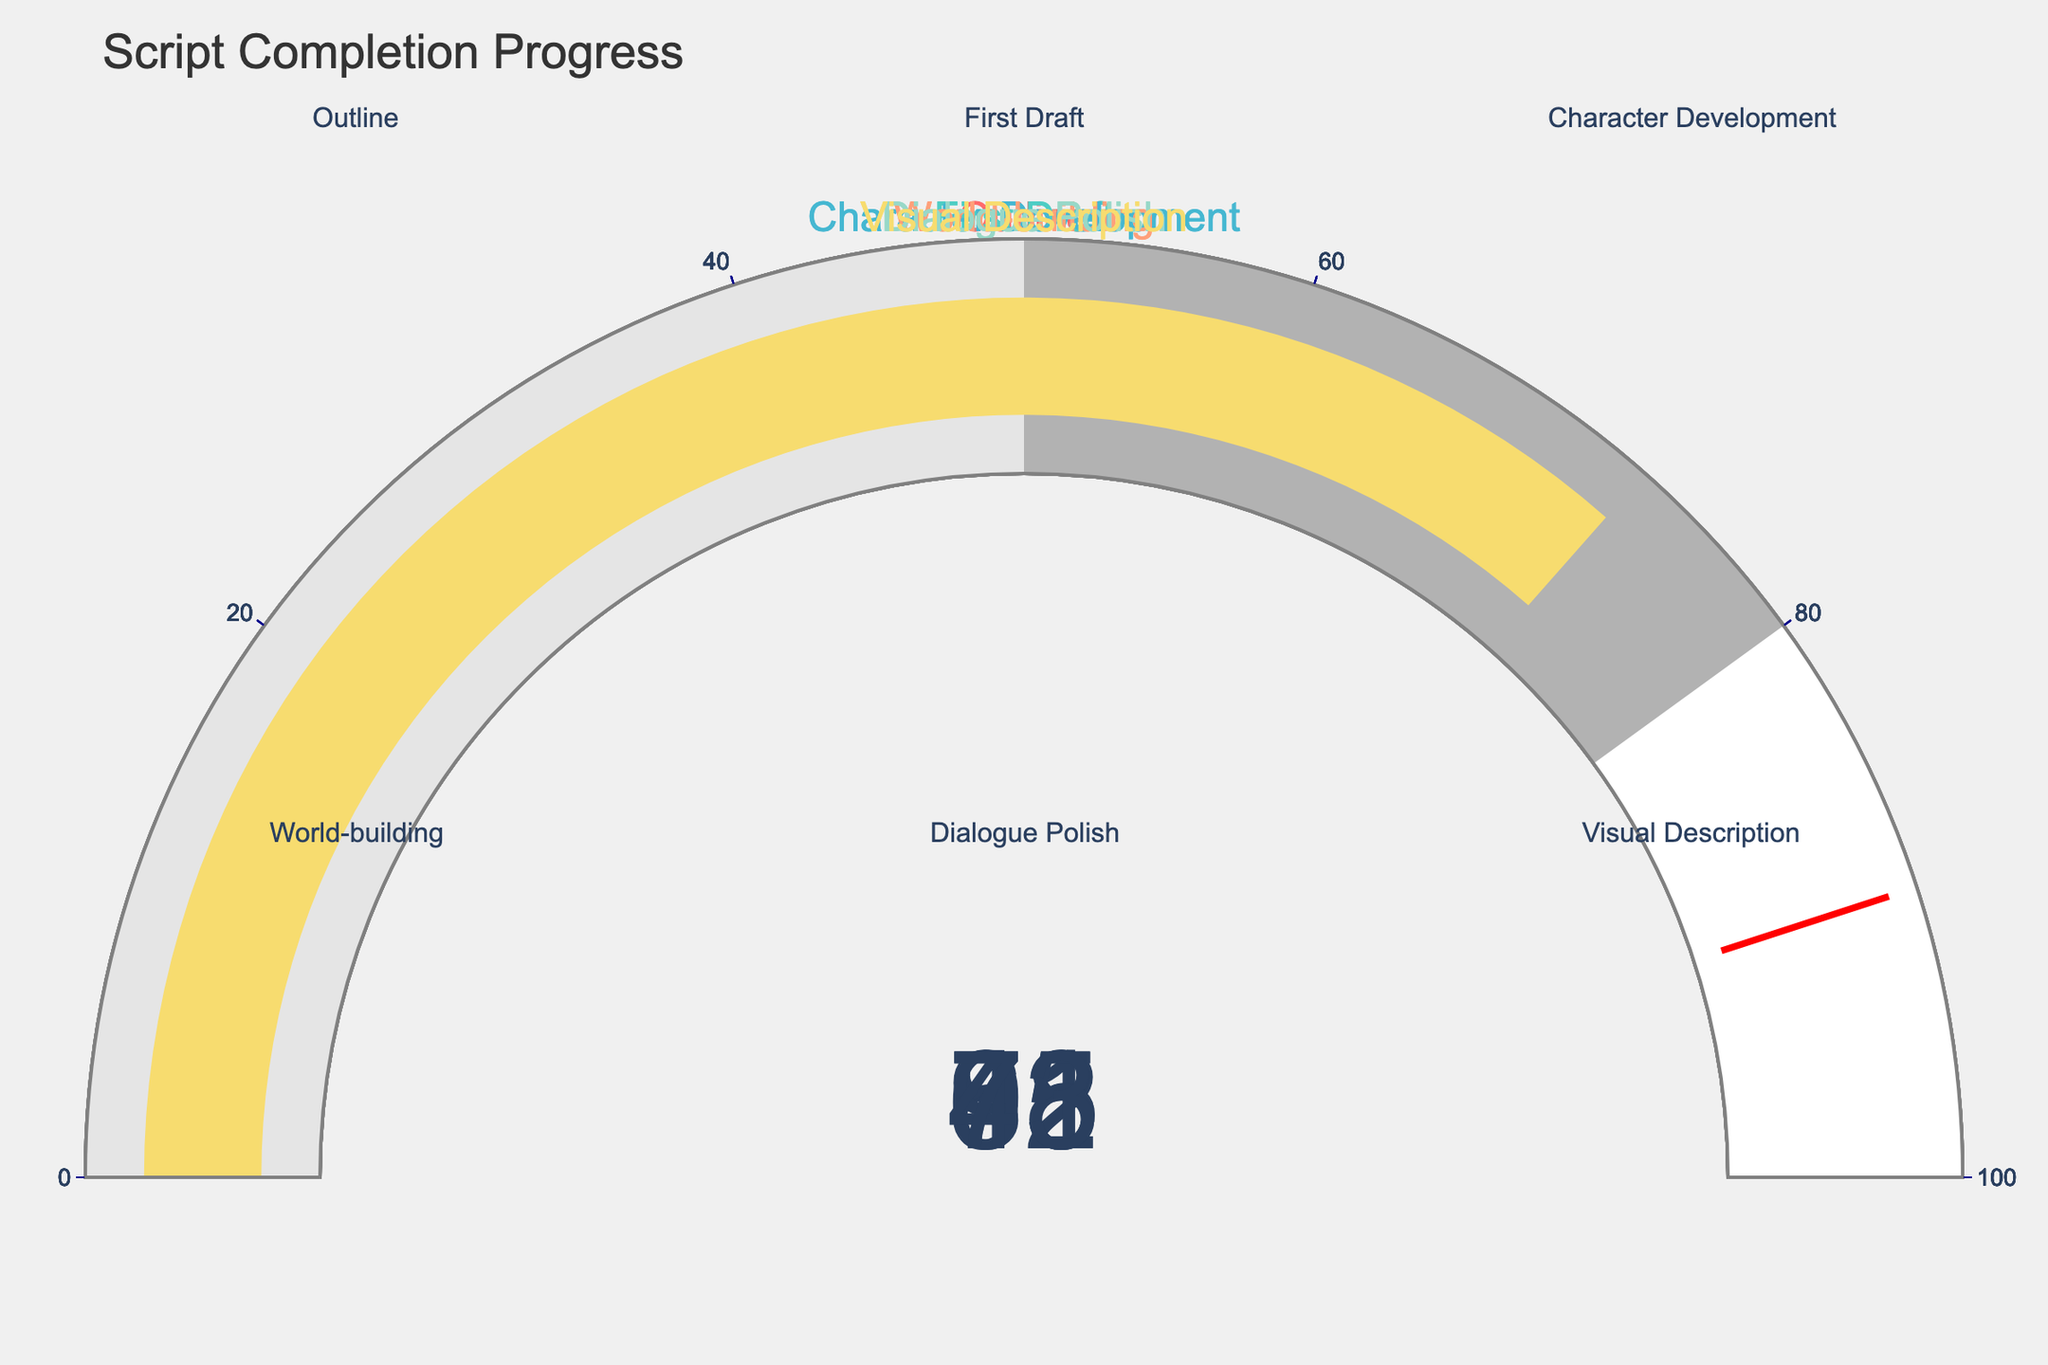How many script stages are shown in the figure? There are six gauges, one for each stage in the script completion process.
Answer: Six Which script stage has the highest completion percentage? By looking at the values on the gauges, the "World-building" stage has the highest completion percentage at 91%.
Answer: World-building Which script stage has the lowest completion percentage? The "Dialogue Polish" stage has the lowest completion percentage at 45%.
Answer: Dialogue Polish What is the average completion percentage of all script stages? Add all the percentages and divide by the number of stages: (85 + 62 + 78 + 91 + 45 + 73) / 6 = 434 / 6 ≈ 72.33
Answer: 72.33 What is the completion percentage difference between the "Outline" and "First Draft" stages? Subtract the percentage of the "First Draft" stage from the "Outline" stage: 85 - 62 = 23
Answer: 23 Which script stages have completion percentages greater than 75%? The stages with completion percentages greater than 75% are "Outline" (85%), "Character Development" (78%), and "World-building" (91%).
Answer: Outline, Character Development, World-building What is the sum of the completion percentages for "Dialogue Polish" and "Visual Description"? Add the completion percentages of both stages: 45 + 73 = 118
Answer: 118 Which completion percentage is closer to the median value of all script stages? First, list the percentages in order: 45, 62, 73, 78, 85, 91. The median is the average of the middle two values: (73 + 78) / 2 = 75.5. The closest value to 75.5 is 78 (Character Development).
Answer: Character Development Is the "Visual Description" stage more complete than the "First Draft" stage? By comparing the completion percentages, "Visual Description" (73%) is more complete than "First Draft" (62%).
Answer: Yes Which stages have completion percentages below 50%? The "Dialogue Polish" stage is the only stage with a completion percentage below 50%.
Answer: Dialogue Polish 